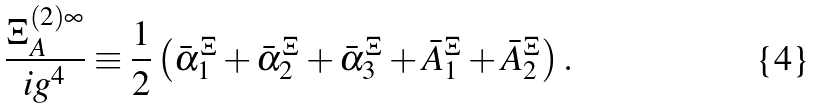Convert formula to latex. <formula><loc_0><loc_0><loc_500><loc_500>\frac { \Xi _ { A } ^ { ( 2 ) \infty } } { i g ^ { 4 } } \equiv \frac { 1 } { 2 } \left ( \bar { \alpha } _ { 1 } ^ { \Xi } + \bar { \alpha } _ { 2 } ^ { \Xi } + \bar { \alpha } _ { 3 } ^ { \Xi } + \bar { A } _ { 1 } ^ { \Xi } + \bar { A } _ { 2 } ^ { \Xi } \right ) .</formula> 